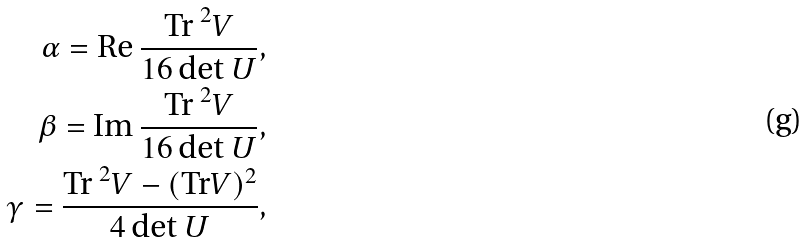<formula> <loc_0><loc_0><loc_500><loc_500>\alpha = \text {Re } \frac { \text {Tr } ^ { 2 } V } { 1 6 \, \text {det } U } , \\ \beta = \text {Im } \frac { \text {Tr } ^ { 2 } V } { 1 6 \, \text {det } U } , \\ \gamma = \frac { \text {Tr } ^ { 2 } V - ( \text {Tr} V ) ^ { 2 } } { 4 \, \text {det } U } ,</formula> 